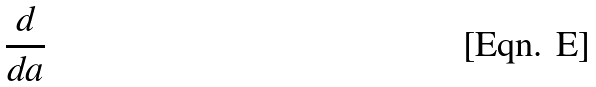<formula> <loc_0><loc_0><loc_500><loc_500>\frac { d } { d a }</formula> 